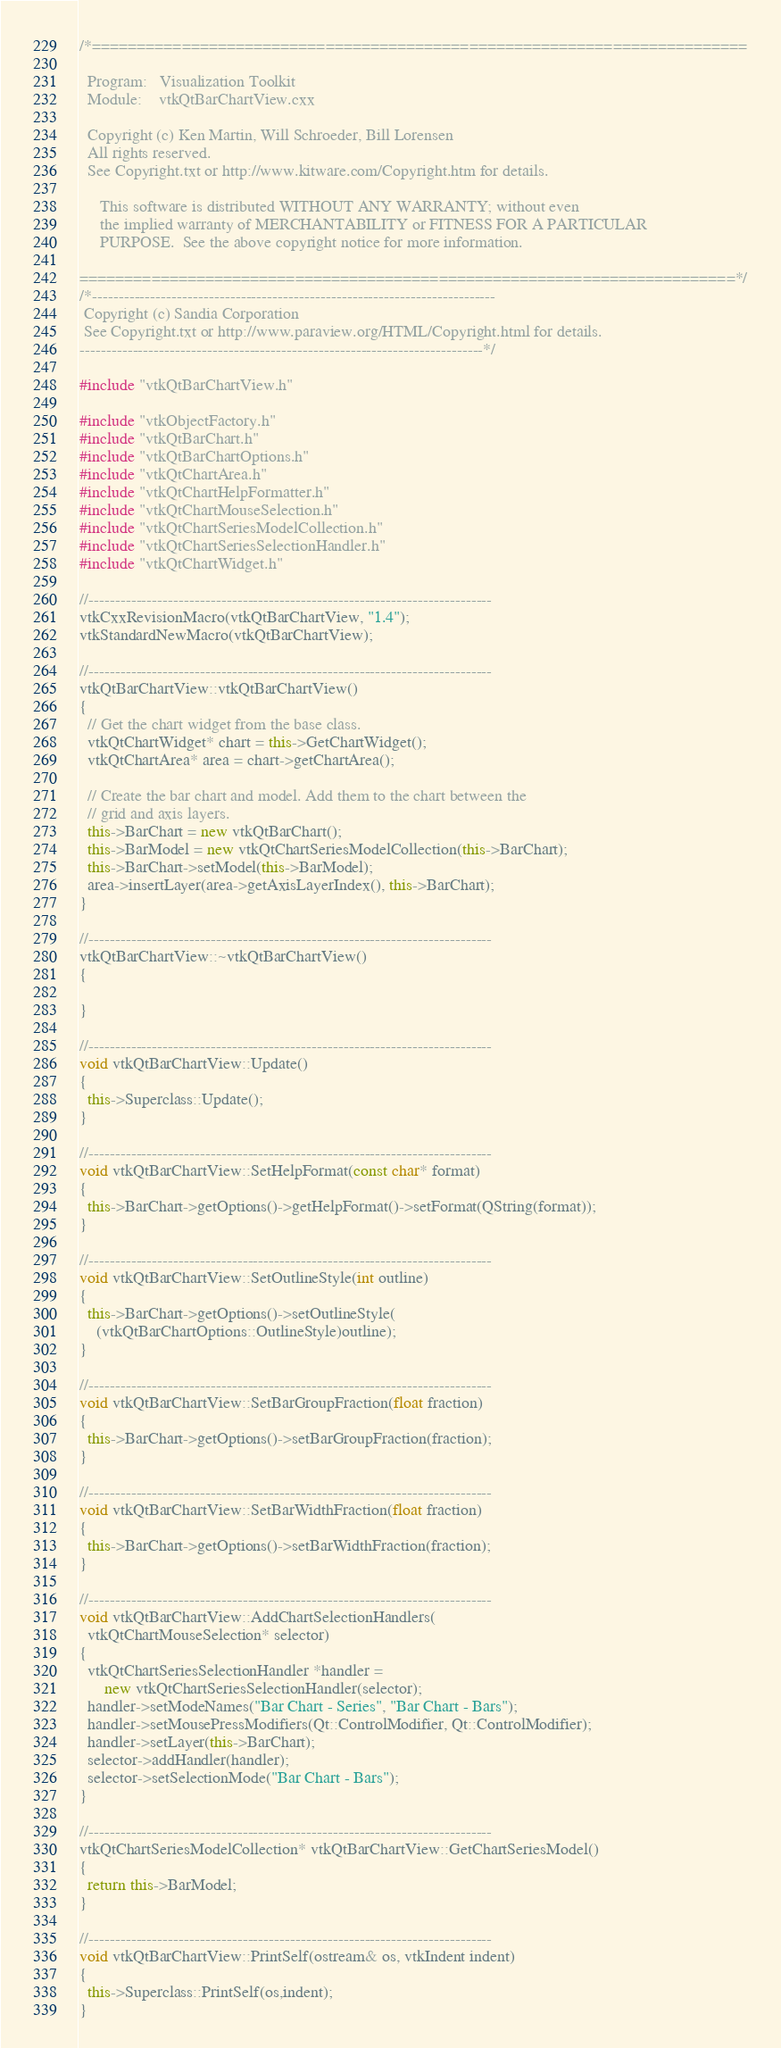Convert code to text. <code><loc_0><loc_0><loc_500><loc_500><_C++_>/*=========================================================================

  Program:   Visualization Toolkit
  Module:    vtkQtBarChartView.cxx

  Copyright (c) Ken Martin, Will Schroeder, Bill Lorensen
  All rights reserved.
  See Copyright.txt or http://www.kitware.com/Copyright.htm for details.

     This software is distributed WITHOUT ANY WARRANTY; without even
     the implied warranty of MERCHANTABILITY or FITNESS FOR A PARTICULAR
     PURPOSE.  See the above copyright notice for more information.

=========================================================================*/
/*----------------------------------------------------------------------------
 Copyright (c) Sandia Corporation
 See Copyright.txt or http://www.paraview.org/HTML/Copyright.html for details.
----------------------------------------------------------------------------*/

#include "vtkQtBarChartView.h"

#include "vtkObjectFactory.h"
#include "vtkQtBarChart.h"
#include "vtkQtBarChartOptions.h"
#include "vtkQtChartArea.h"
#include "vtkQtChartHelpFormatter.h"
#include "vtkQtChartMouseSelection.h"
#include "vtkQtChartSeriesModelCollection.h"
#include "vtkQtChartSeriesSelectionHandler.h"
#include "vtkQtChartWidget.h"

//----------------------------------------------------------------------------
vtkCxxRevisionMacro(vtkQtBarChartView, "1.4");
vtkStandardNewMacro(vtkQtBarChartView);

//----------------------------------------------------------------------------
vtkQtBarChartView::vtkQtBarChartView()
{
  // Get the chart widget from the base class.
  vtkQtChartWidget* chart = this->GetChartWidget();
  vtkQtChartArea* area = chart->getChartArea();

  // Create the bar chart and model. Add them to the chart between the
  // grid and axis layers.
  this->BarChart = new vtkQtBarChart();
  this->BarModel = new vtkQtChartSeriesModelCollection(this->BarChart);
  this->BarChart->setModel(this->BarModel);
  area->insertLayer(area->getAxisLayerIndex(), this->BarChart);
}

//----------------------------------------------------------------------------
vtkQtBarChartView::~vtkQtBarChartView()
{

}

//----------------------------------------------------------------------------
void vtkQtBarChartView::Update()
{
  this->Superclass::Update();
}

//----------------------------------------------------------------------------
void vtkQtBarChartView::SetHelpFormat(const char* format)
{
  this->BarChart->getOptions()->getHelpFormat()->setFormat(QString(format));
}

//----------------------------------------------------------------------------
void vtkQtBarChartView::SetOutlineStyle(int outline)
{
  this->BarChart->getOptions()->setOutlineStyle(
    (vtkQtBarChartOptions::OutlineStyle)outline);
}

//----------------------------------------------------------------------------
void vtkQtBarChartView::SetBarGroupFraction(float fraction)
{
  this->BarChart->getOptions()->setBarGroupFraction(fraction);
}

//----------------------------------------------------------------------------
void vtkQtBarChartView::SetBarWidthFraction(float fraction)
{
  this->BarChart->getOptions()->setBarWidthFraction(fraction);
}

//----------------------------------------------------------------------------
void vtkQtBarChartView::AddChartSelectionHandlers(
  vtkQtChartMouseSelection* selector)
{
  vtkQtChartSeriesSelectionHandler *handler =
      new vtkQtChartSeriesSelectionHandler(selector);
  handler->setModeNames("Bar Chart - Series", "Bar Chart - Bars");
  handler->setMousePressModifiers(Qt::ControlModifier, Qt::ControlModifier);
  handler->setLayer(this->BarChart);
  selector->addHandler(handler);
  selector->setSelectionMode("Bar Chart - Bars");
}

//----------------------------------------------------------------------------
vtkQtChartSeriesModelCollection* vtkQtBarChartView::GetChartSeriesModel()
{
  return this->BarModel;
}

//----------------------------------------------------------------------------
void vtkQtBarChartView::PrintSelf(ostream& os, vtkIndent indent)
{
  this->Superclass::PrintSelf(os,indent);
}
</code> 